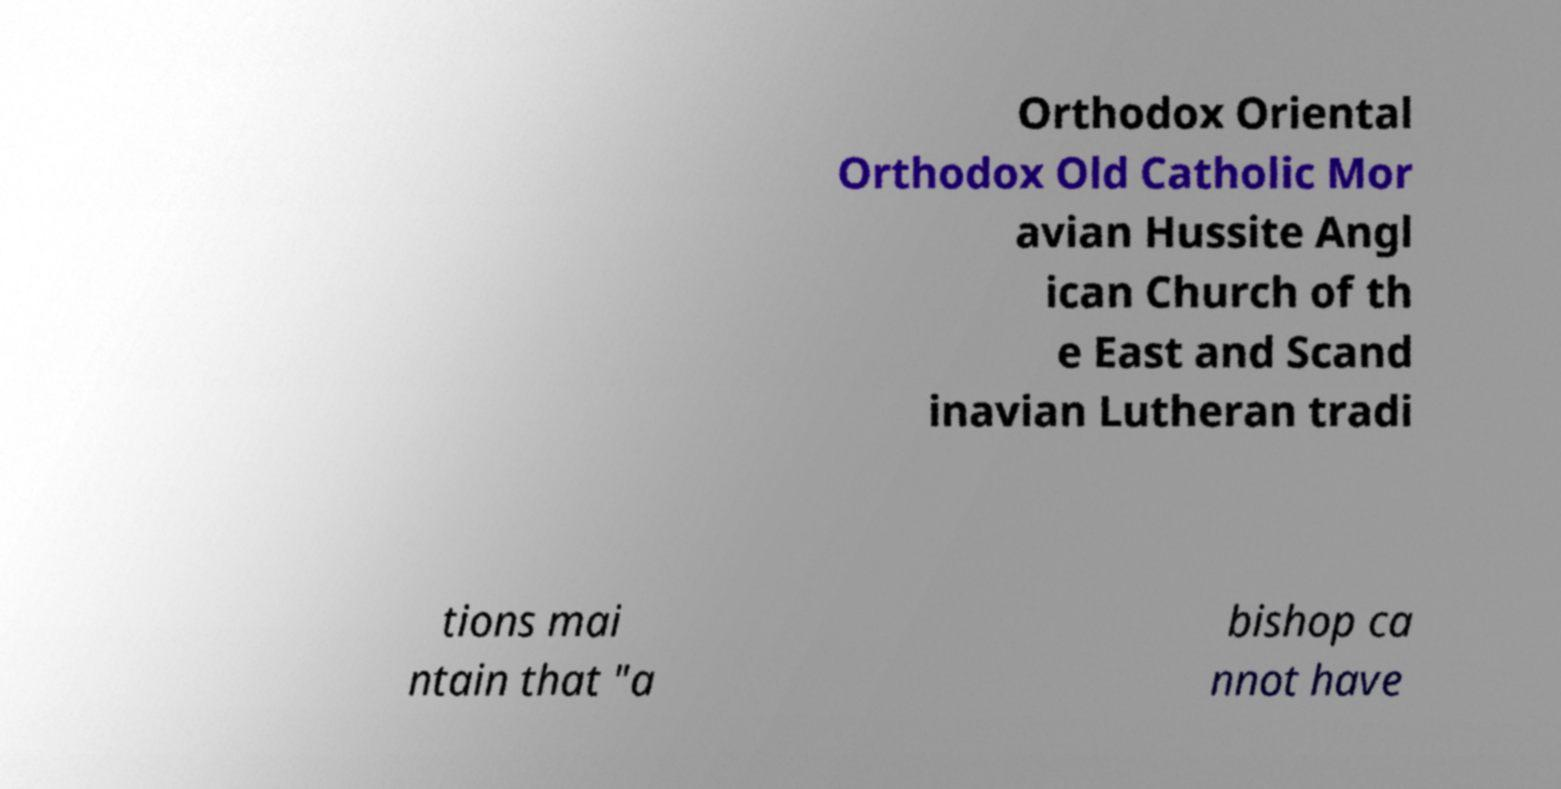Can you accurately transcribe the text from the provided image for me? Orthodox Oriental Orthodox Old Catholic Mor avian Hussite Angl ican Church of th e East and Scand inavian Lutheran tradi tions mai ntain that "a bishop ca nnot have 